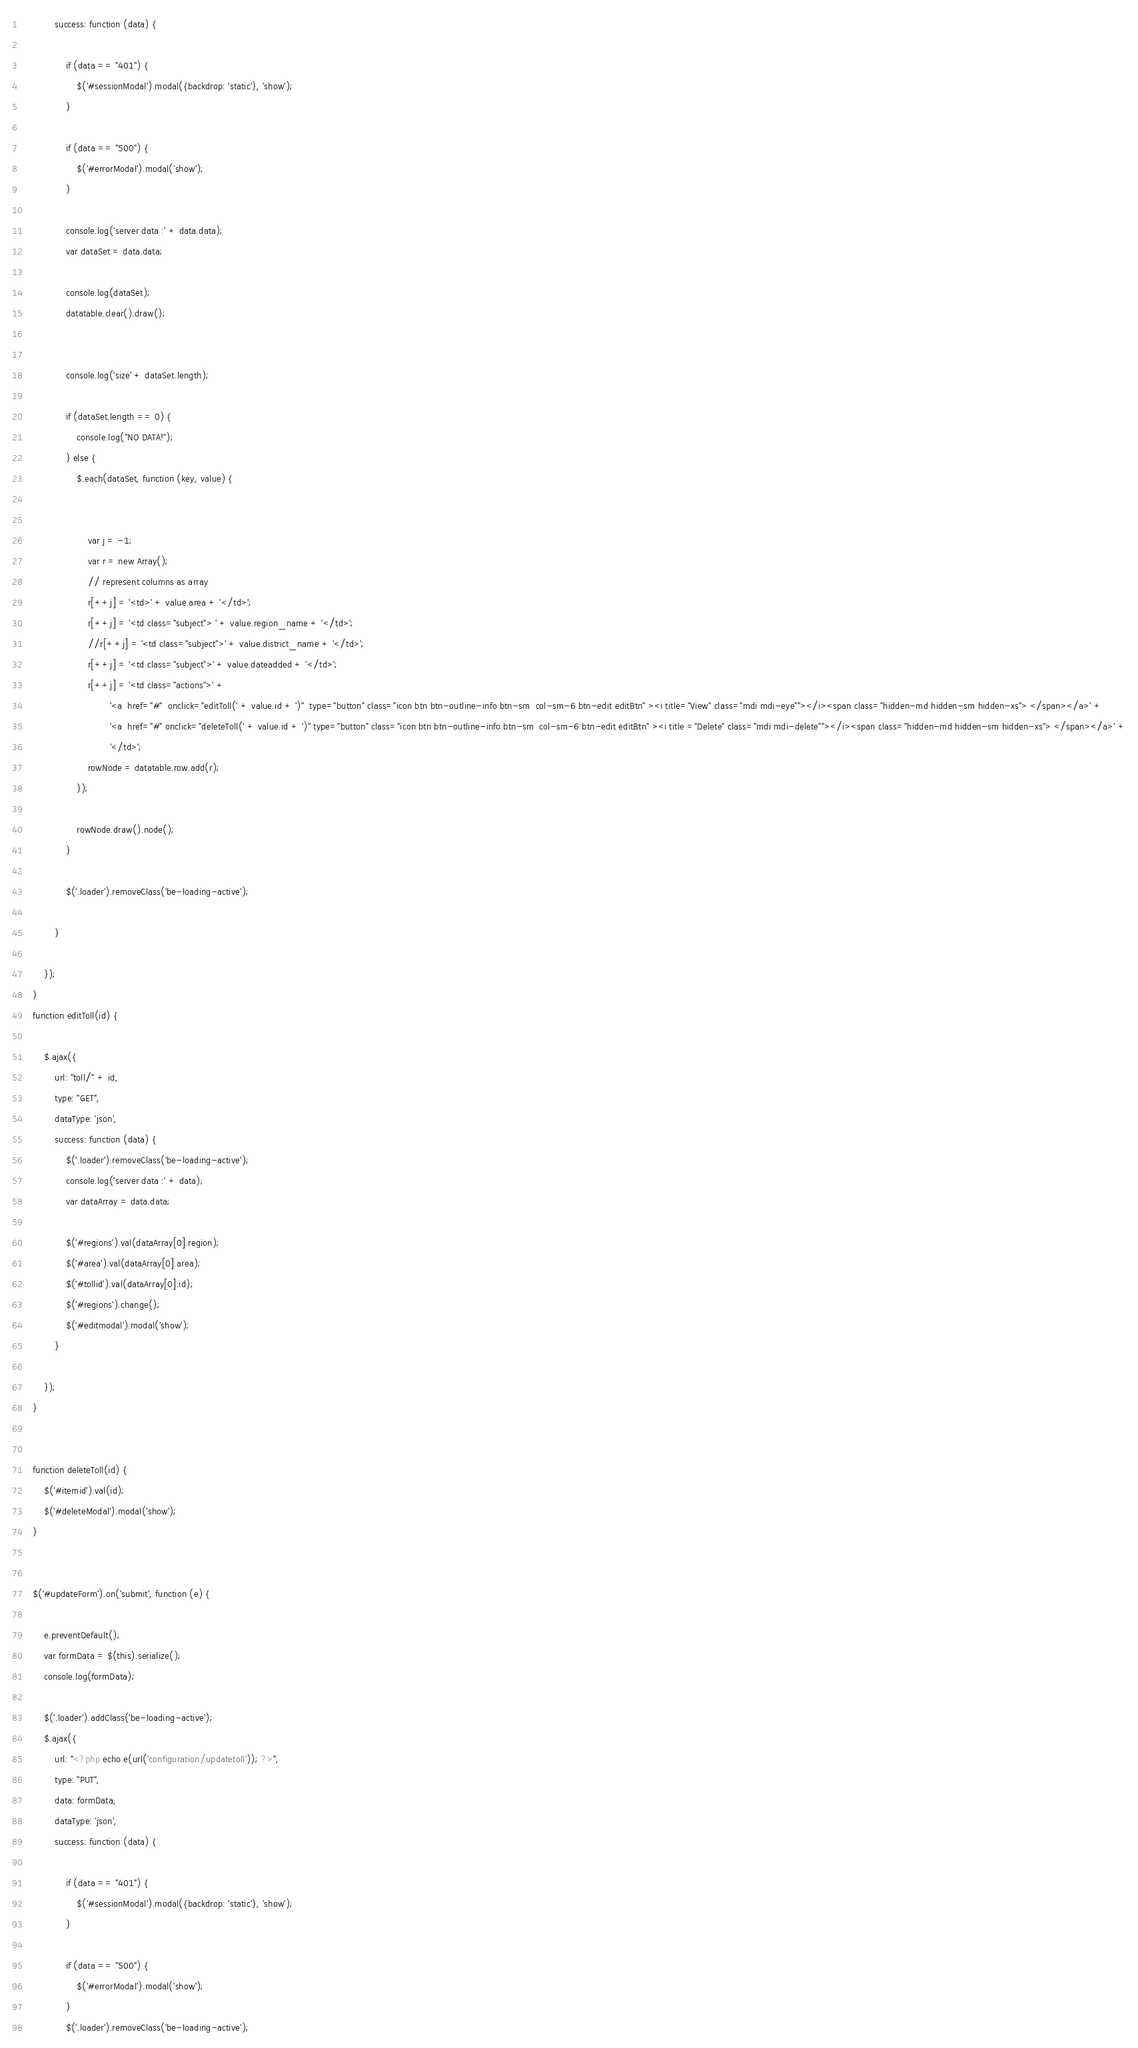Convert code to text. <code><loc_0><loc_0><loc_500><loc_500><_PHP_>            success: function (data) {

                if (data == "401") {
                    $('#sessionModal').modal({backdrop: 'static'}, 'show');
                }

                if (data == "500") {
                    $('#errorModal').modal('show');
                }

                console.log('server data :' + data.data);
                var dataSet = data.data;

                console.log(dataSet);
                datatable.clear().draw();


                console.log('size' + dataSet.length);

                if (dataSet.length == 0) {
                    console.log("NO DATA!");
                } else {
                    $.each(dataSet, function (key, value) {


                        var j = -1;
                        var r = new Array();
                        // represent columns as array
                        r[++j] = '<td>' + value.area + '</td>';
                        r[++j] = '<td class="subject"> ' + value.region_name + '</td>';
                        //r[++j] = '<td class="subject">' + value.district_name + '</td>';
                        r[++j] = '<td class="subject">' + value.dateadded + '</td>';
                        r[++j] = '<td class="actions">' +
                                '<a  href="#"  onclick="editToll(' + value.id + ')"  type="button" class="icon btn btn-outline-info btn-sm  col-sm-6 btn-edit editBtn" ><i title="View" class="mdi mdi-eye""></i><span class="hidden-md hidden-sm hidden-xs"> </span></a>' +
                                '<a  href="#" onclick="deleteToll(' + value.id + ')" type="button" class="icon btn btn-outline-info btn-sm  col-sm-6 btn-edit editBtn" ><i title ="Delete" class="mdi mdi-delete""></i><span class="hidden-md hidden-sm hidden-xs"> </span></a>' +
                                '</td>';
                        rowNode = datatable.row.add(r);
                    });

                    rowNode.draw().node();
                }

                $('.loader').removeClass('be-loading-active');

            }

        });
    }
    function editToll(id) {

        $.ajax({
            url: "toll/" + id,
            type: "GET",
            dataType: 'json',
            success: function (data) {
                $('.loader').removeClass('be-loading-active');
                console.log('server data :' + data);
                var dataArray = data.data;

                $('#regions').val(dataArray[0].region);
                $('#area').val(dataArray[0].area);
                $('#tollid').val(dataArray[0].id);
                $('#regions').change();
                $('#editmodal').modal('show');
            }

        });
    }


    function deleteToll(id) {
        $('#itemid').val(id);
        $('#deleteModal').modal('show');
    }


    $('#updateForm').on('submit', function (e) {

        e.preventDefault();
        var formData = $(this).serialize();
        console.log(formData);

        $('.loader').addClass('be-loading-active');
        $.ajax({
            url: "<?php echo e(url('configuration/updatetoll')); ?>",
            type: "PUT",
            data: formData,
            dataType: 'json',
            success: function (data) {

                if (data == "401") {
                    $('#sessionModal').modal({backdrop: 'static'}, 'show');
                }

                if (data == "500") {
                    $('#errorModal').modal('show');
                }
                $('.loader').removeClass('be-loading-active');</code> 